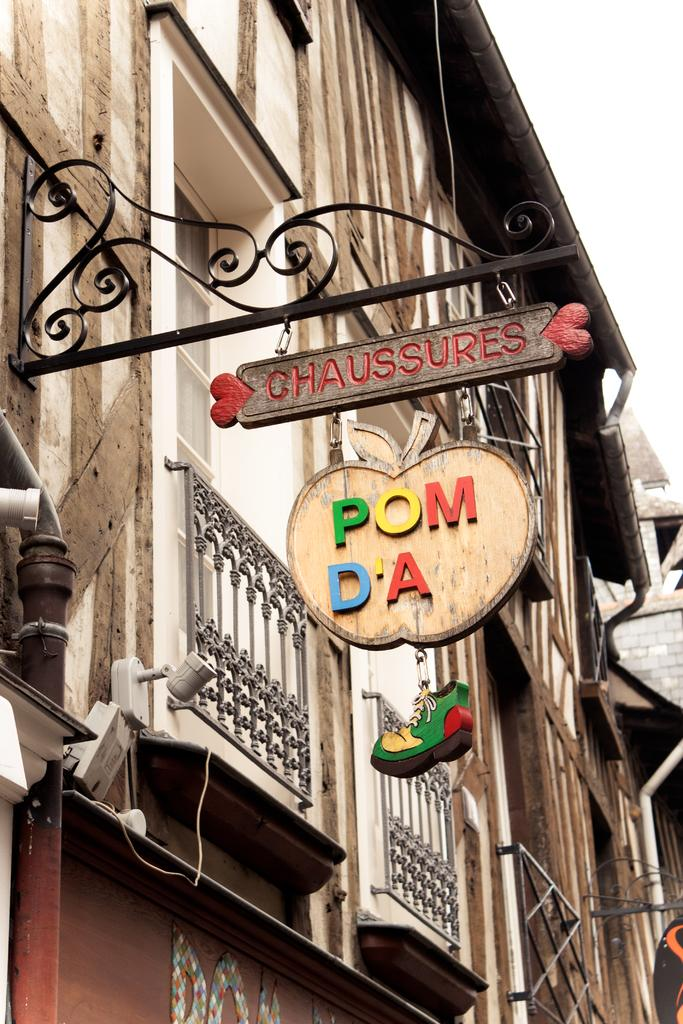<image>
Give a short and clear explanation of the subsequent image. a street signe for Chaussures at Pom Da with a shoe dangling beneath 